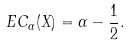<formula> <loc_0><loc_0><loc_500><loc_500>E C _ { \alpha } ( X ) = \alpha - \frac { 1 } { 2 } .</formula> 